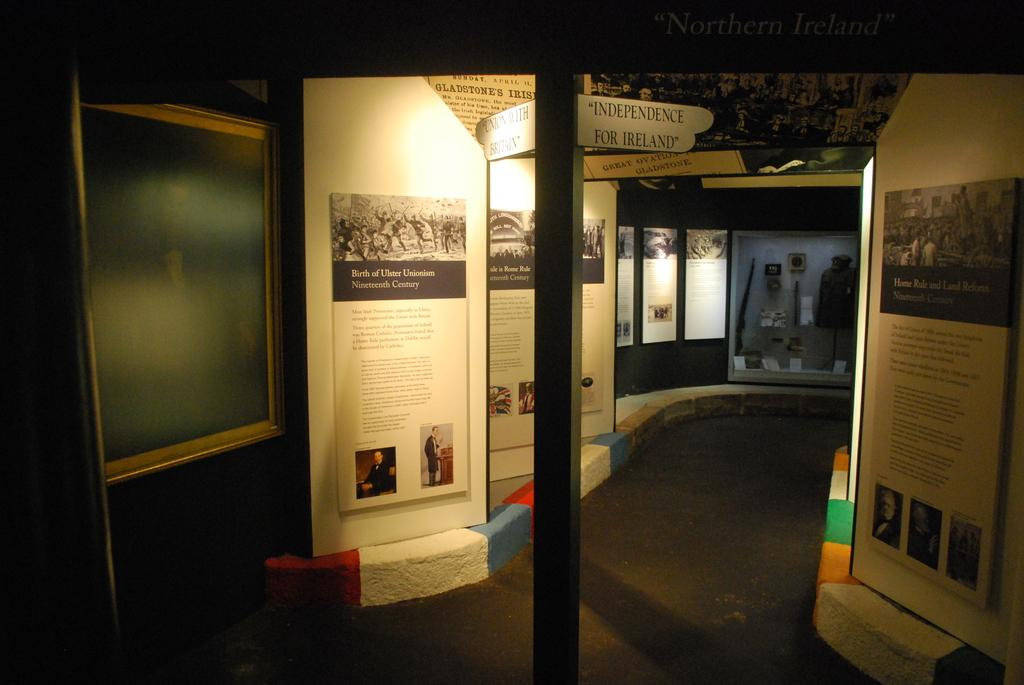What is placed on the floor in the image? There is an iron pole on the floor in the image. What can be seen beside the iron pole? There are posters beside the iron pole. What type of signage is present in the image? There are name boards in the image. What other objects can be seen in the image? There are other objects visible in the image. What type of jewel is hanging from the iron pole in the image? There is no jewel hanging from the iron pole in the image; it is an iron pole with posters beside it. 